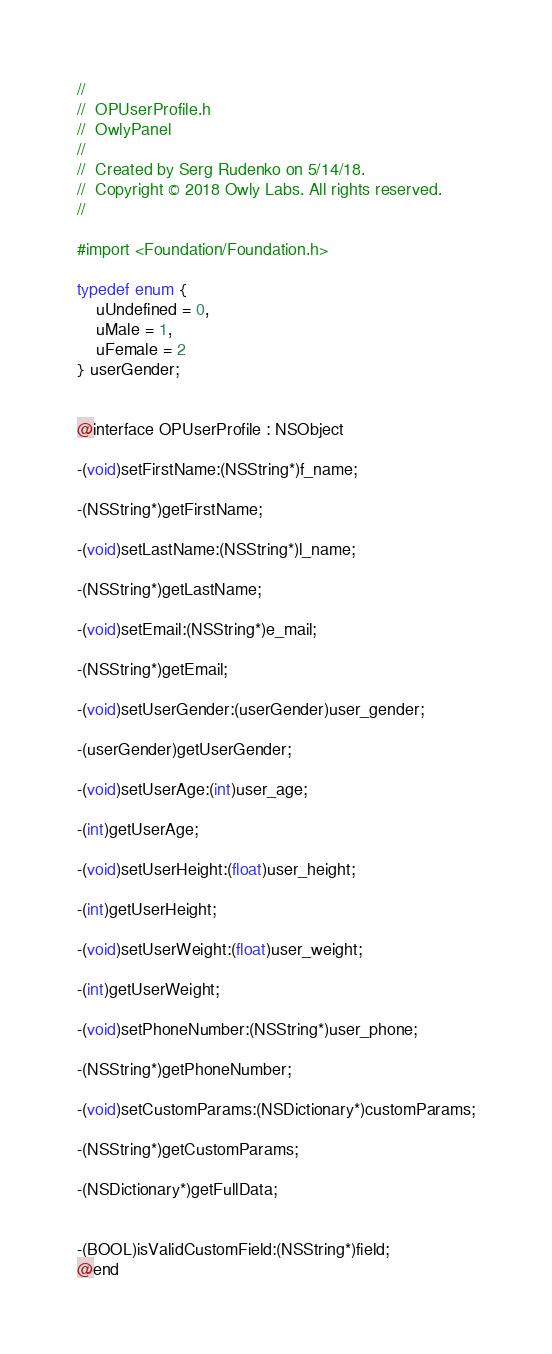<code> <loc_0><loc_0><loc_500><loc_500><_C_>//
//  OPUserProfile.h
//  OwlyPanel
//
//  Created by Serg Rudenko on 5/14/18.
//  Copyright © 2018 Owly Labs. All rights reserved.
//

#import <Foundation/Foundation.h>

typedef enum {
    uUndefined = 0,
    uMale = 1,
    uFemale = 2
} userGender;


@interface OPUserProfile : NSObject

-(void)setFirstName:(NSString*)f_name;

-(NSString*)getFirstName;

-(void)setLastName:(NSString*)l_name;

-(NSString*)getLastName;

-(void)setEmail:(NSString*)e_mail;

-(NSString*)getEmail;

-(void)setUserGender:(userGender)user_gender;

-(userGender)getUserGender;

-(void)setUserAge:(int)user_age;

-(int)getUserAge;

-(void)setUserHeight:(float)user_height;

-(int)getUserHeight;

-(void)setUserWeight:(float)user_weight;

-(int)getUserWeight;

-(void)setPhoneNumber:(NSString*)user_phone;

-(NSString*)getPhoneNumber;

-(void)setCustomParams:(NSDictionary*)customParams;

-(NSString*)getCustomParams;

-(NSDictionary*)getFullData;


-(BOOL)isValidCustomField:(NSString*)field;
@end
</code> 